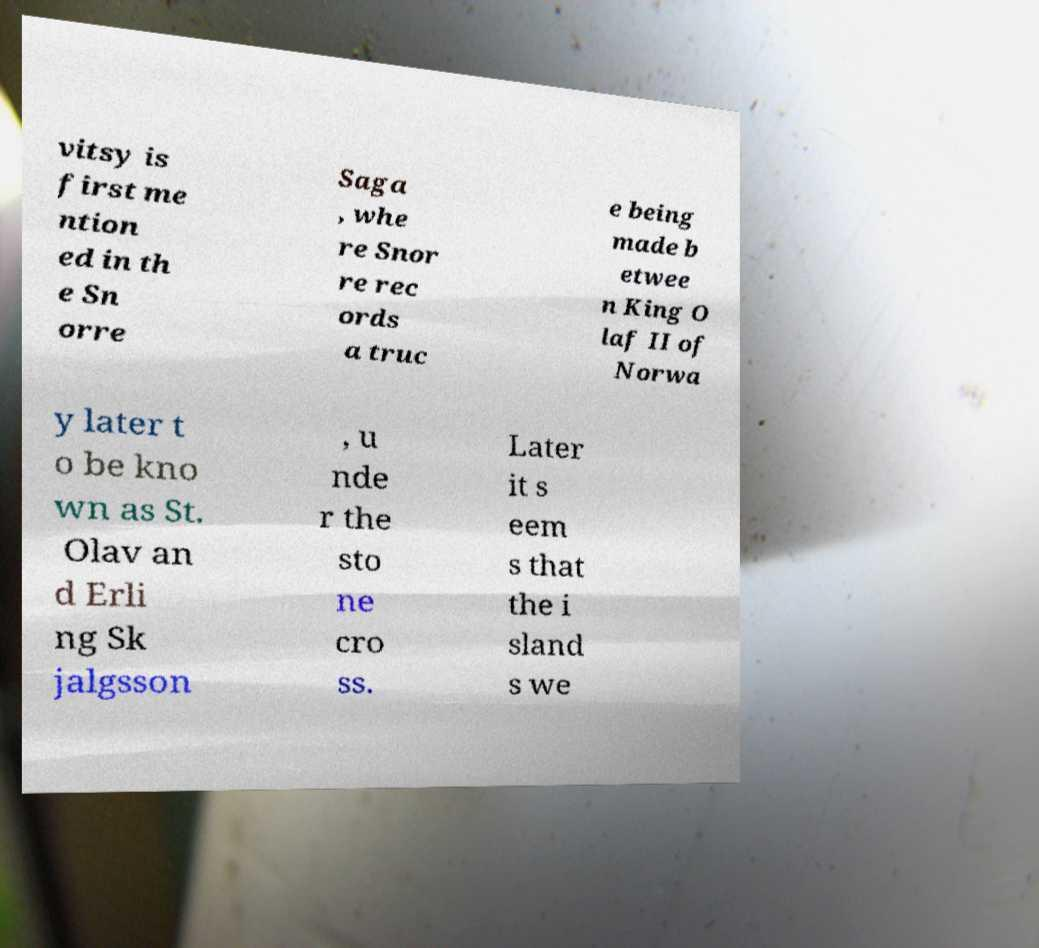Can you read and provide the text displayed in the image?This photo seems to have some interesting text. Can you extract and type it out for me? vitsy is first me ntion ed in th e Sn orre Saga , whe re Snor re rec ords a truc e being made b etwee n King O laf II of Norwa y later t o be kno wn as St. Olav an d Erli ng Sk jalgsson , u nde r the sto ne cro ss. Later it s eem s that the i sland s we 